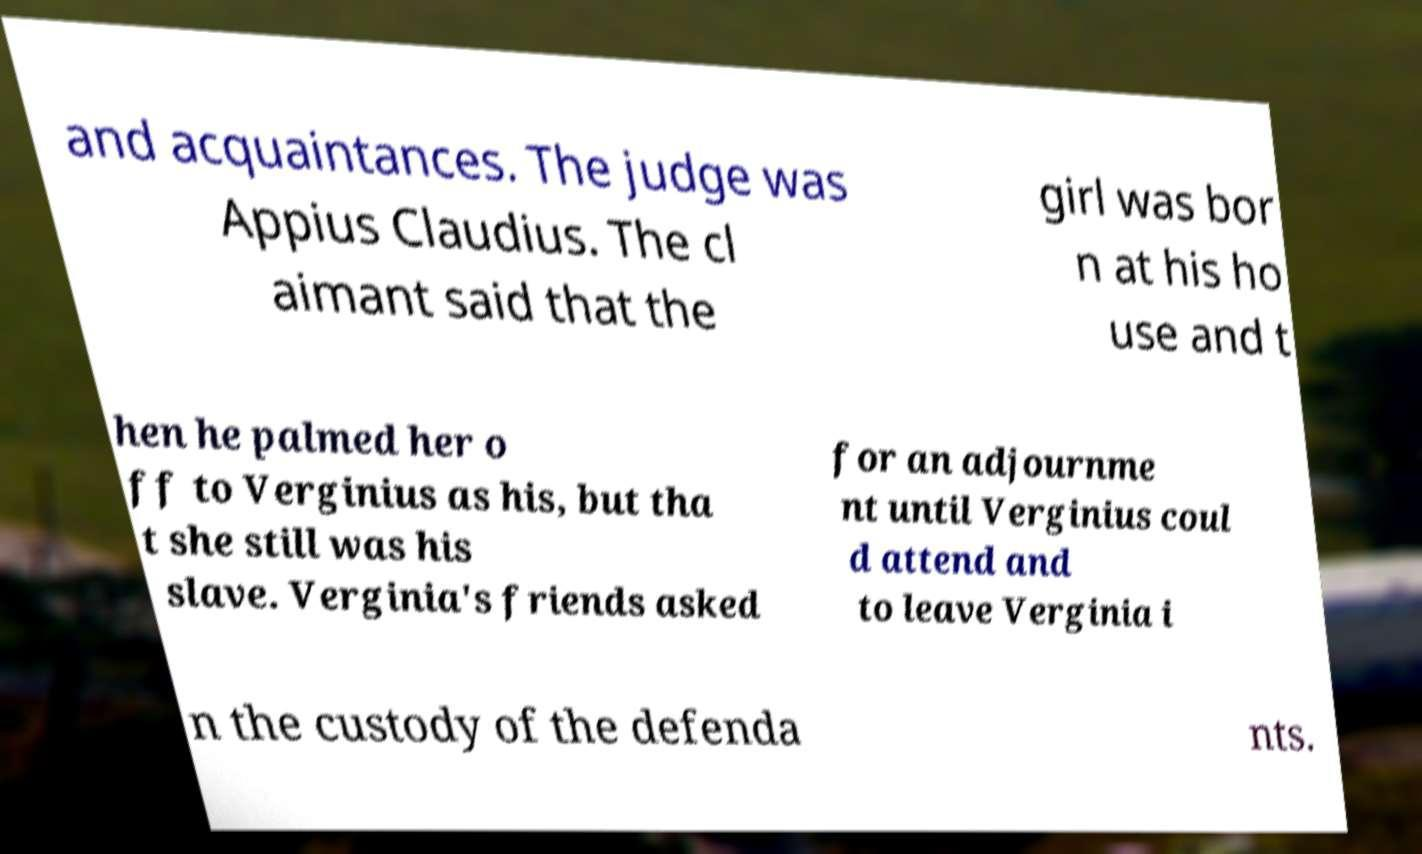I need the written content from this picture converted into text. Can you do that? and acquaintances. The judge was Appius Claudius. The cl aimant said that the girl was bor n at his ho use and t hen he palmed her o ff to Verginius as his, but tha t she still was his slave. Verginia's friends asked for an adjournme nt until Verginius coul d attend and to leave Verginia i n the custody of the defenda nts. 